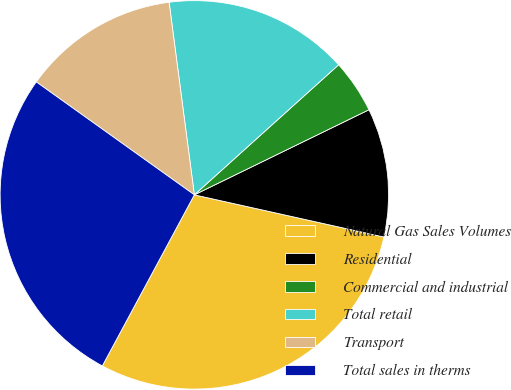Convert chart. <chart><loc_0><loc_0><loc_500><loc_500><pie_chart><fcel>Natural Gas Sales Volumes<fcel>Residential<fcel>Commercial and industrial<fcel>Total retail<fcel>Transport<fcel>Total sales in therms<nl><fcel>29.37%<fcel>10.7%<fcel>4.46%<fcel>15.4%<fcel>13.05%<fcel>27.02%<nl></chart> 